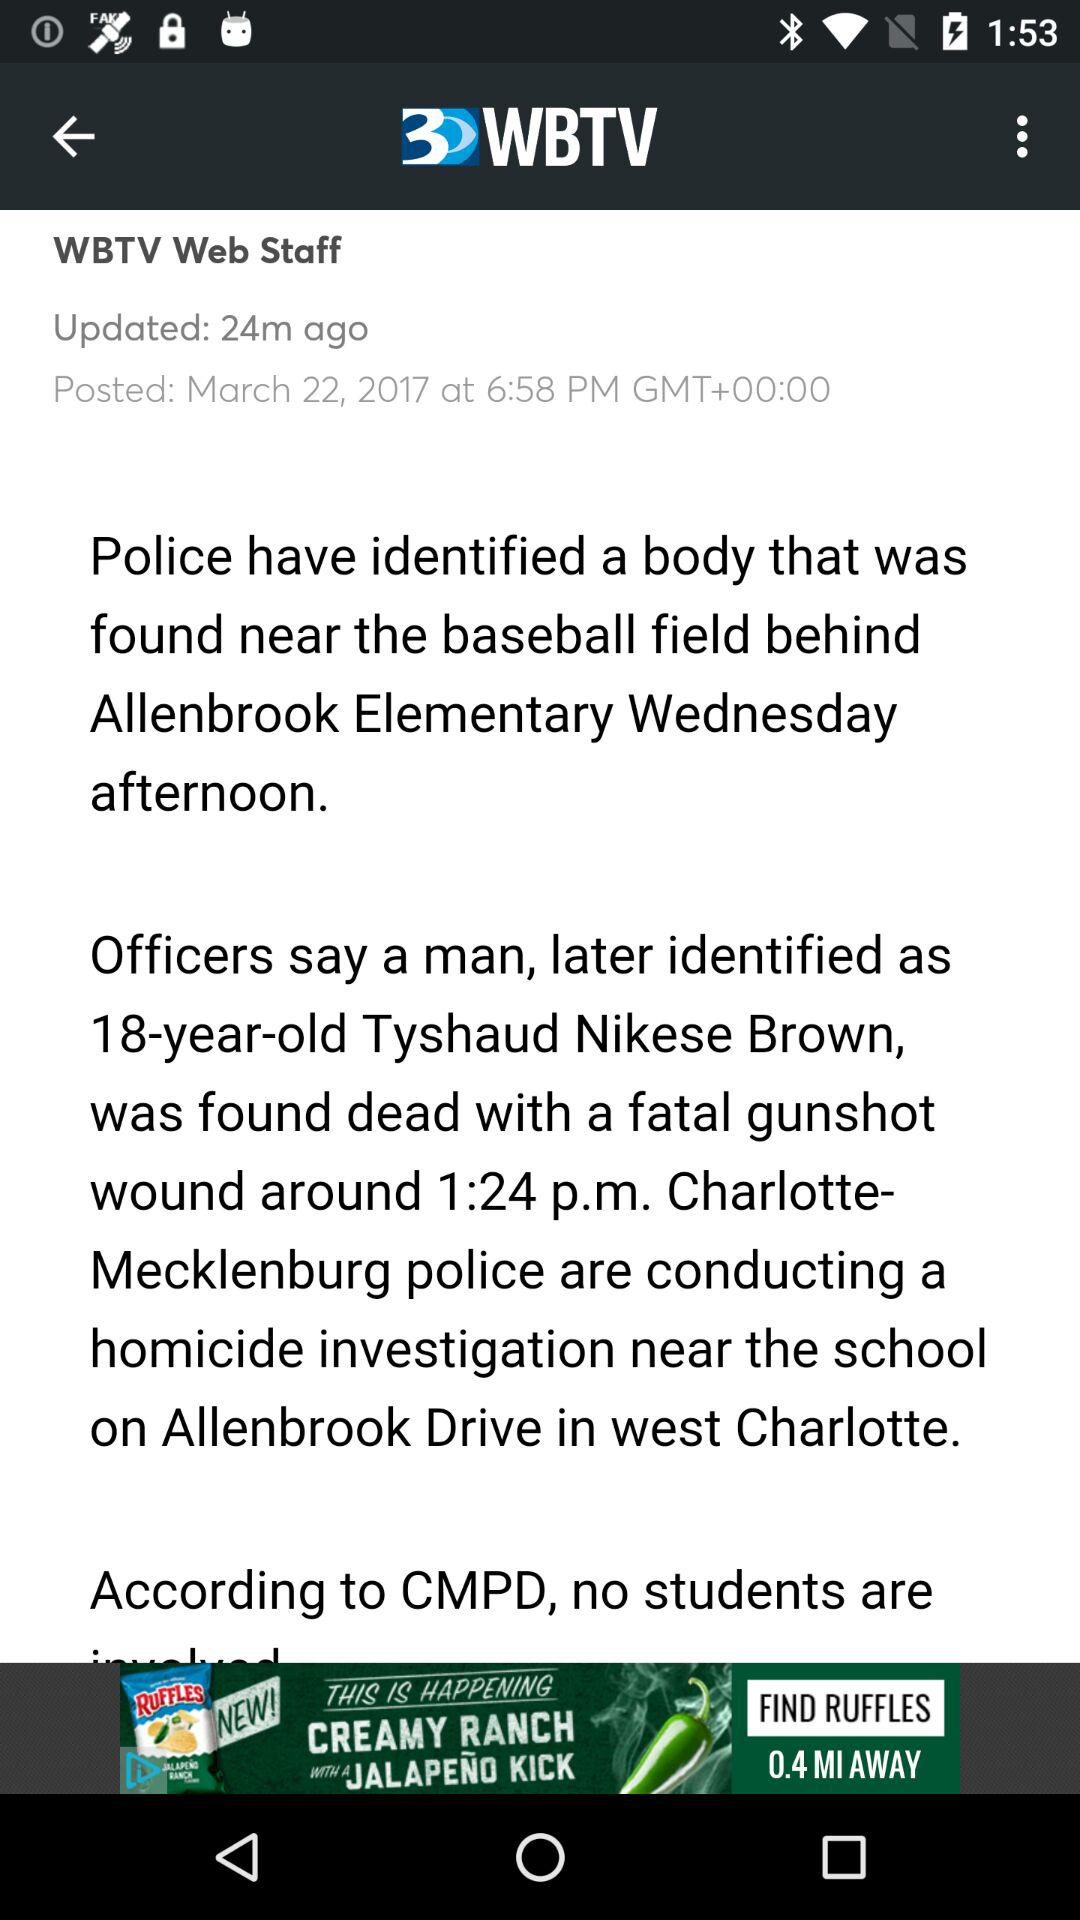How many minutes ago was the article updated?
Answer the question using a single word or phrase. 24 